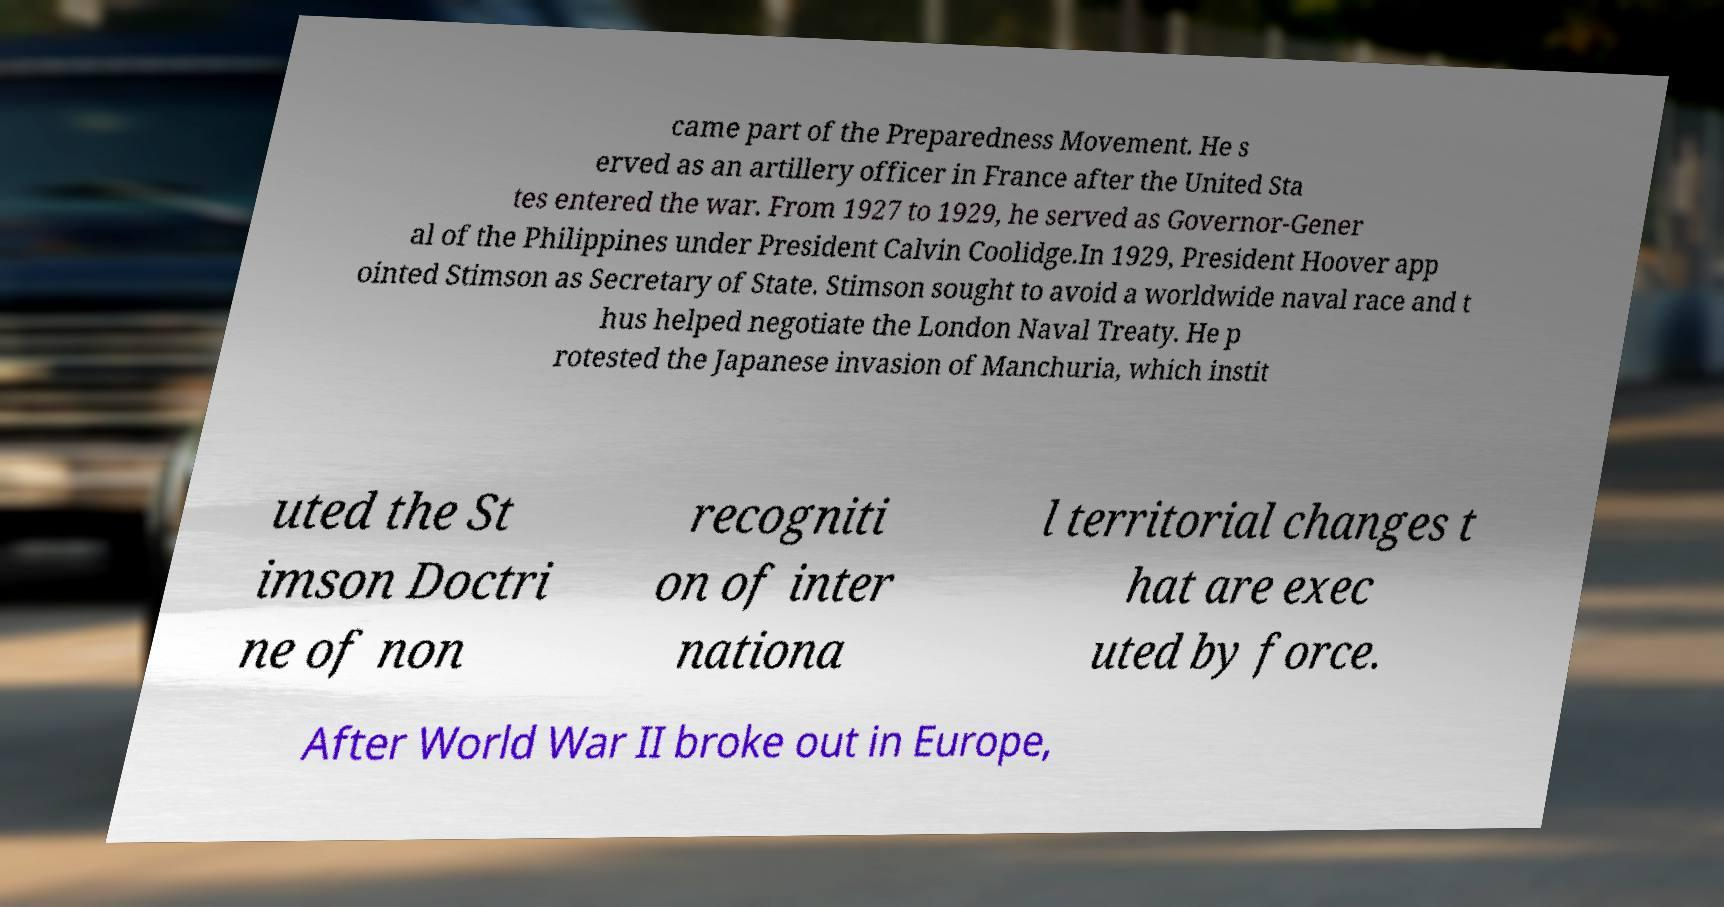Could you extract and type out the text from this image? came part of the Preparedness Movement. He s erved as an artillery officer in France after the United Sta tes entered the war. From 1927 to 1929, he served as Governor-Gener al of the Philippines under President Calvin Coolidge.In 1929, President Hoover app ointed Stimson as Secretary of State. Stimson sought to avoid a worldwide naval race and t hus helped negotiate the London Naval Treaty. He p rotested the Japanese invasion of Manchuria, which instit uted the St imson Doctri ne of non recogniti on of inter nationa l territorial changes t hat are exec uted by force. After World War II broke out in Europe, 